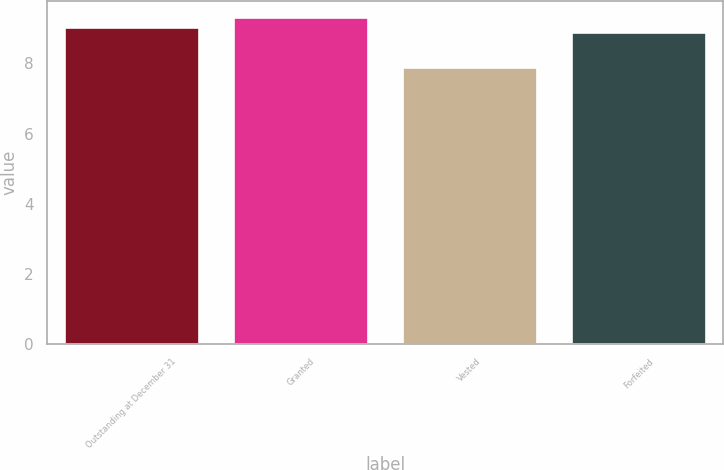Convert chart to OTSL. <chart><loc_0><loc_0><loc_500><loc_500><bar_chart><fcel>Outstanding at December 31<fcel>Granted<fcel>Vested<fcel>Forfeited<nl><fcel>9.04<fcel>9.33<fcel>7.9<fcel>8.9<nl></chart> 